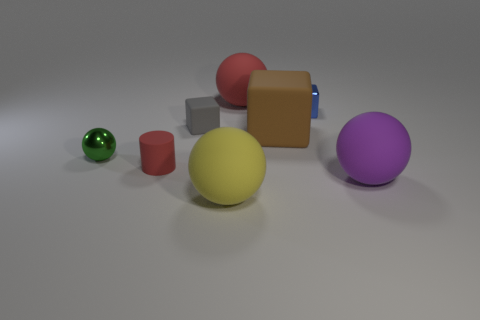What shape is the rubber object that is the same color as the cylinder?
Your answer should be very brief. Sphere. Is there anything else that is the same material as the big block?
Provide a short and direct response. Yes. Is the material of the object behind the blue object the same as the red thing that is in front of the small green ball?
Offer a very short reply. Yes. There is a matte block that is on the right side of the yellow object in front of the red object in front of the green metal sphere; what color is it?
Give a very brief answer. Brown. What number of other things are there of the same shape as the big yellow object?
Give a very brief answer. 3. Do the large cube and the small matte block have the same color?
Your answer should be compact. No. What number of objects are cyan blocks or large objects in front of the gray block?
Offer a terse response. 3. Are there any green spheres of the same size as the red matte ball?
Ensure brevity in your answer.  No. Is the material of the large yellow sphere the same as the small gray thing?
Your answer should be compact. Yes. What number of things are big purple cylinders or small red rubber cylinders?
Give a very brief answer. 1. 